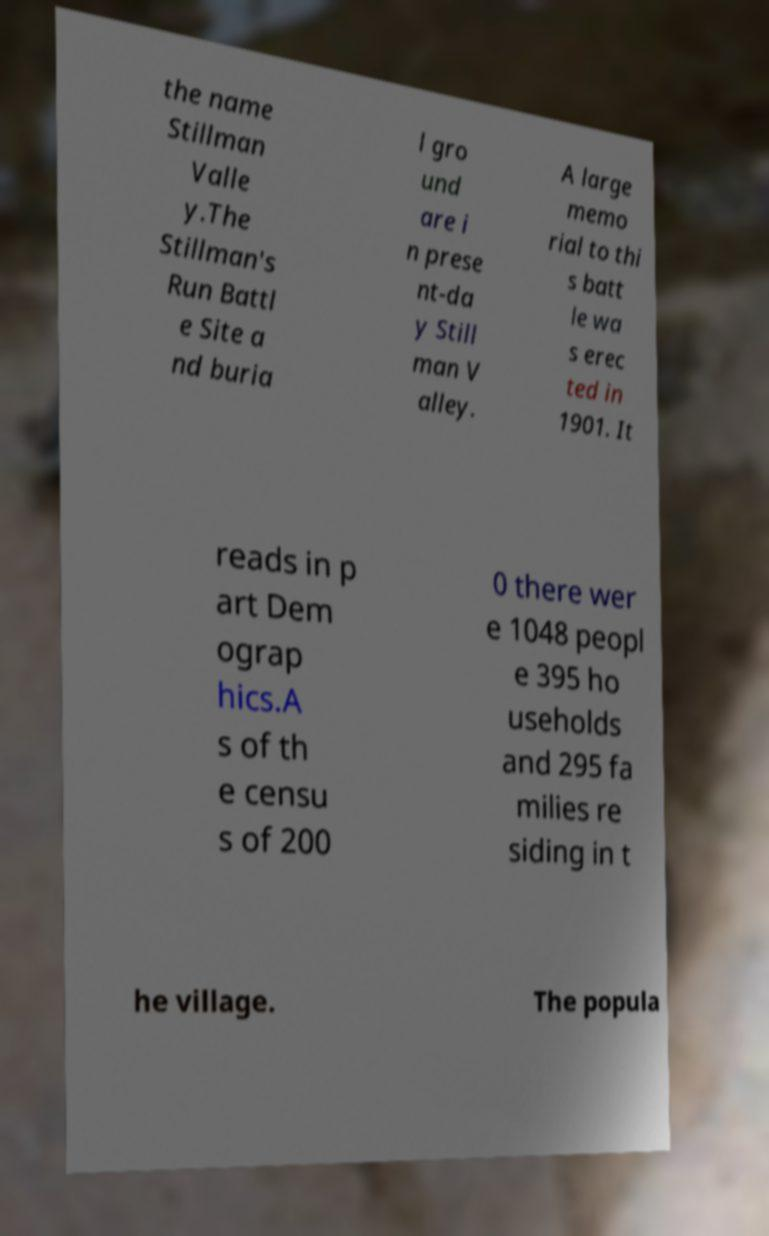For documentation purposes, I need the text within this image transcribed. Could you provide that? the name Stillman Valle y.The Stillman's Run Battl e Site a nd buria l gro und are i n prese nt-da y Still man V alley. A large memo rial to thi s batt le wa s erec ted in 1901. It reads in p art Dem ograp hics.A s of th e censu s of 200 0 there wer e 1048 peopl e 395 ho useholds and 295 fa milies re siding in t he village. The popula 